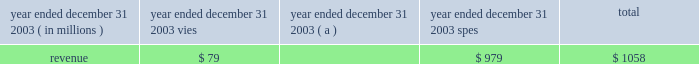J.p .
Morgan chase & co .
/ 2003 annual report 49 off 2013balance sheet arrangements and contractual cash obligations special-purpose entities special-purpose entities ( 201cspes 201d ) , special-purpose vehicles ( 201cspvs 201d ) , or variable-interest entities ( 201cvies 201d ) , are an important part of the financial markets , providing market liquidity by facili- tating investors 2019 access to specific portfolios of assets and risks .
Spes are not operating entities ; typically they are established for a single , discrete purpose , have a limited life and have no employees .
The basic spe structure involves a company selling assets to the spe .
The spe funds the asset purchase by selling securities to investors .
To insulate investors from creditors of other entities , including the seller of the assets , spes are often structured to be bankruptcy-remote .
Spes are critical to the functioning of many investor markets , including , for example , the market for mortgage-backed securities , other asset-backed securities and commercial paper .
Jpmorgan chase is involved with spes in three broad categories of transactions : loan securi- tizations ( through 201cqualifying 201d spes ) , multi-seller conduits , and client intermediation .
Capital is held , as appropriate , against all spe-related transactions and related exposures such as deriva- tive transactions and lending-related commitments .
The firm has no commitments to issue its own stock to support any spe transaction , and its policies require that transactions with spes be conducted at arm 2019s length and reflect market pric- ing .
Consistent with this policy , no jpmorgan chase employee is permitted to invest in spes with which the firm is involved where such investment would violate the firm 2019s worldwide rules of conduct .
These rules prohibit employees from self- dealing and prohibit employees from acting on behalf of the firm in transactions with which they or their family have any significant financial interest .
For certain liquidity commitments to spes , the firm could be required to provide funding if the credit rating of jpmorgan chase bank were downgraded below specific levels , primarily p-1 , a-1 and f1 for moody 2019s , standard & poor 2019s and fitch , respectively .
The amount of these liquidity commitments was $ 34.0 billion at december 31 , 2003 .
If jpmorgan chase bank were required to provide funding under these commitments , the firm could be replaced as liquidity provider .
Additionally , with respect to the multi-seller conduits and structured commercial loan vehicles for which jpmorgan chase bank has extended liq- uidity commitments , the bank could facilitate the sale or refi- nancing of the assets in the spe in order to provide liquidity .
Of these liquidity commitments to spes , $ 27.7 billion is included in the firm 2019s total other unfunded commitments to extend credit included in the table on the following page .
As a result of the consolidation of multi-seller conduits in accordance with fin 46 , $ 6.3 billion of these commitments are excluded from the table , as the underlying assets of the spe have been included on the firm 2019s consolidated balance sheet .
The table summarizes certain revenue information related to vies with which the firm has significant involvement , and qualifying spes: .
( a ) includes consolidated and nonconsolidated asset-backed commercial paper conduits for a consistent presentation of 2003 results .
The revenue reported in the table above represents primarily servicing fee income .
The firm also has exposure to certain vie vehicles arising from derivative transactions with vies ; these transactions are recorded at fair value on the firm 2019s consolidated balance sheet with changes in fair value ( i.e. , mark-to-market gains and losses ) recorded in trading revenue .
Such mtm gains and losses are not included in the revenue amounts reported in the table above .
For a further discussion of spes and the firm 2019s accounting for spes , see note 1 on pages 86 201387 , note 13 on pages 100 2013103 , and note 14 on pages 103 2013106 of this annual report .
Contractual cash obligations in the normal course of business , the firm enters into various con- tractual obligations that may require future cash payments .
Contractual obligations at december 31 , 2003 , include long-term debt , trust preferred capital securities , operating leases , contractual purchases and capital expenditures and certain other liabilities .
For a further discussion regarding long-term debt and trust preferred capital securities , see note 18 on pages 109 2013111 of this annual report .
For a further discussion regarding operating leases , see note 27 on page 115 of this annual report .
The accompanying table summarizes jpmorgan chase 2019s off 2013 balance sheet lending-related financial instruments and signifi- cant contractual cash obligations , by remaining maturity , at december 31 , 2003 .
Contractual purchases include commit- ments for future cash expenditures , primarily for services and contracts involving certain forward purchases of securities and commodities .
Capital expenditures primarily represent future cash payments for real estate 2013related obligations and equip- ment .
Contractual purchases and capital expenditures at december 31 , 2003 , reflect the minimum contractual obligation under legally enforceable contracts with contract terms that are both fixed and determinable .
Excluded from the following table are a number of obligations to be settled in cash , primarily in under one year .
These obligations are reflected on the firm 2019s consolidated balance sheet and include deposits ; federal funds purchased and securities sold under repurchase agreements ; other borrowed funds ; purchases of debt and equity instruments that settle within standard market timeframes ( e.g .
Regular-way ) ; derivative payables that do not require physical delivery of the underlying instrument ; and certain purchases of instruments that resulted in settlement failures. .
In 2003 , special purpose entities provided what share of the total revenue of vies and spes? 
Computations: (979 / 1058)
Answer: 0.92533. 